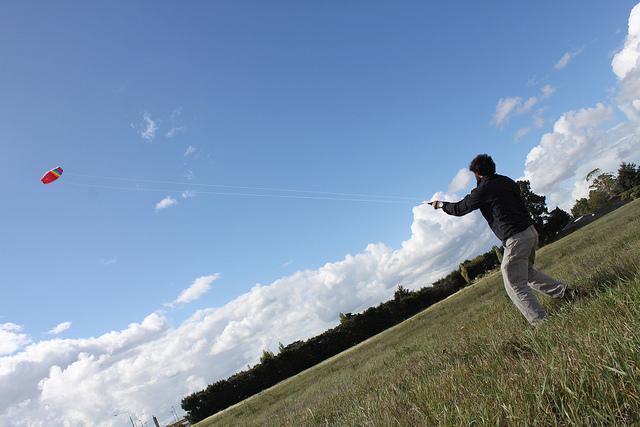How many hands is the man holding the kite with?
Give a very brief answer. 1. How many kites are there?
Give a very brief answer. 1. 